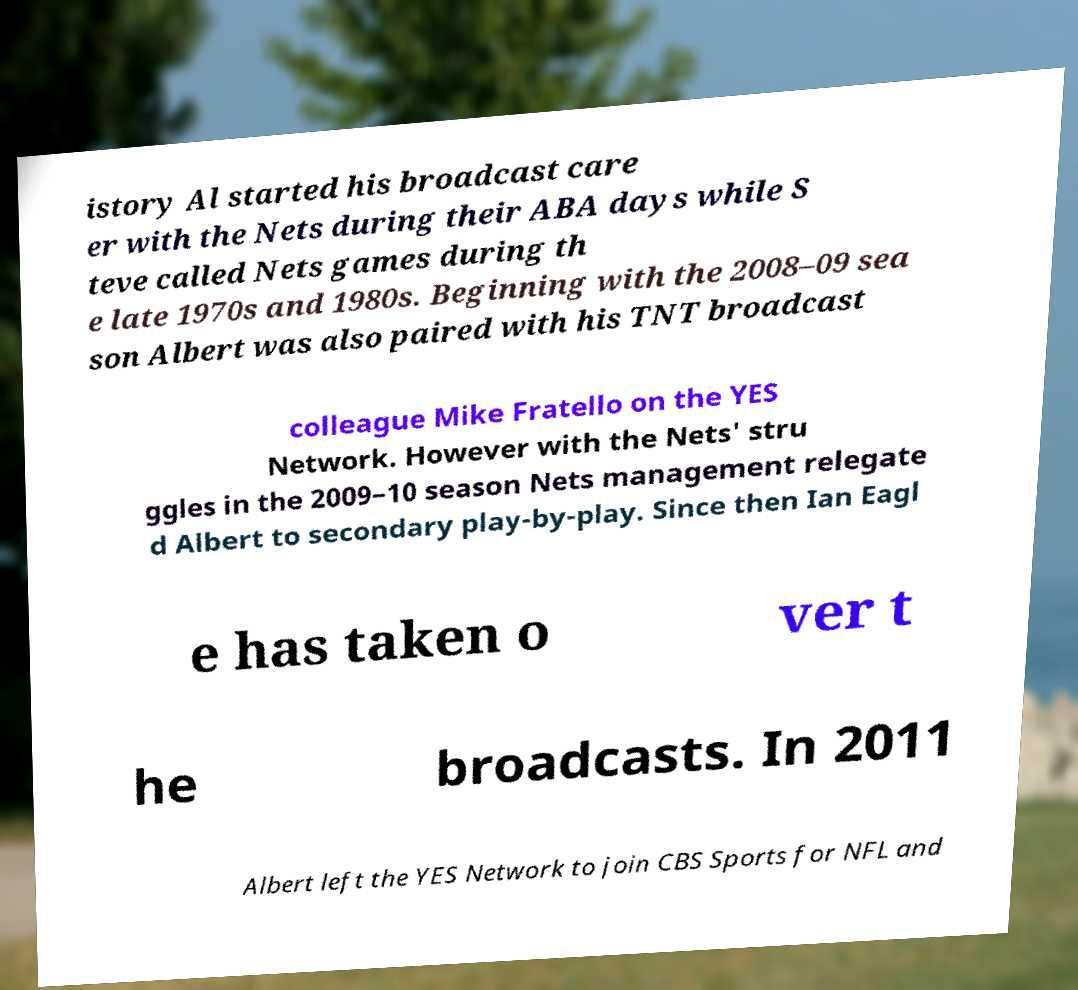Please identify and transcribe the text found in this image. istory Al started his broadcast care er with the Nets during their ABA days while S teve called Nets games during th e late 1970s and 1980s. Beginning with the 2008–09 sea son Albert was also paired with his TNT broadcast colleague Mike Fratello on the YES Network. However with the Nets' stru ggles in the 2009–10 season Nets management relegate d Albert to secondary play-by-play. Since then Ian Eagl e has taken o ver t he broadcasts. In 2011 Albert left the YES Network to join CBS Sports for NFL and 